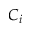Convert formula to latex. <formula><loc_0><loc_0><loc_500><loc_500>C _ { i }</formula> 